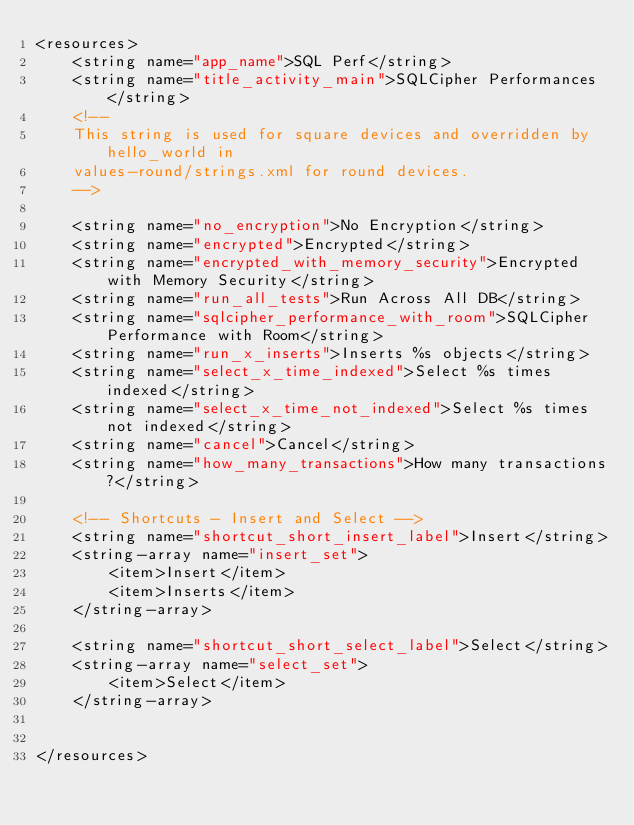<code> <loc_0><loc_0><loc_500><loc_500><_XML_><resources>
    <string name="app_name">SQL Perf</string>
    <string name="title_activity_main">SQLCipher Performances</string>
    <!--
    This string is used for square devices and overridden by hello_world in
    values-round/strings.xml for round devices.
    -->

    <string name="no_encryption">No Encryption</string>
    <string name="encrypted">Encrypted</string>
    <string name="encrypted_with_memory_security">Encrypted with Memory Security</string>
    <string name="run_all_tests">Run Across All DB</string>
    <string name="sqlcipher_performance_with_room">SQLCipher Performance with Room</string>
    <string name="run_x_inserts">Inserts %s objects</string>
    <string name="select_x_time_indexed">Select %s times indexed</string>
    <string name="select_x_time_not_indexed">Select %s times not indexed</string>
    <string name="cancel">Cancel</string>
    <string name="how_many_transactions">How many transactions?</string>

    <!-- Shortcuts - Insert and Select -->
    <string name="shortcut_short_insert_label">Insert</string>
    <string-array name="insert_set">
        <item>Insert</item>
        <item>Inserts</item>
    </string-array>

    <string name="shortcut_short_select_label">Select</string>
    <string-array name="select_set">
        <item>Select</item>
    </string-array>


</resources></code> 